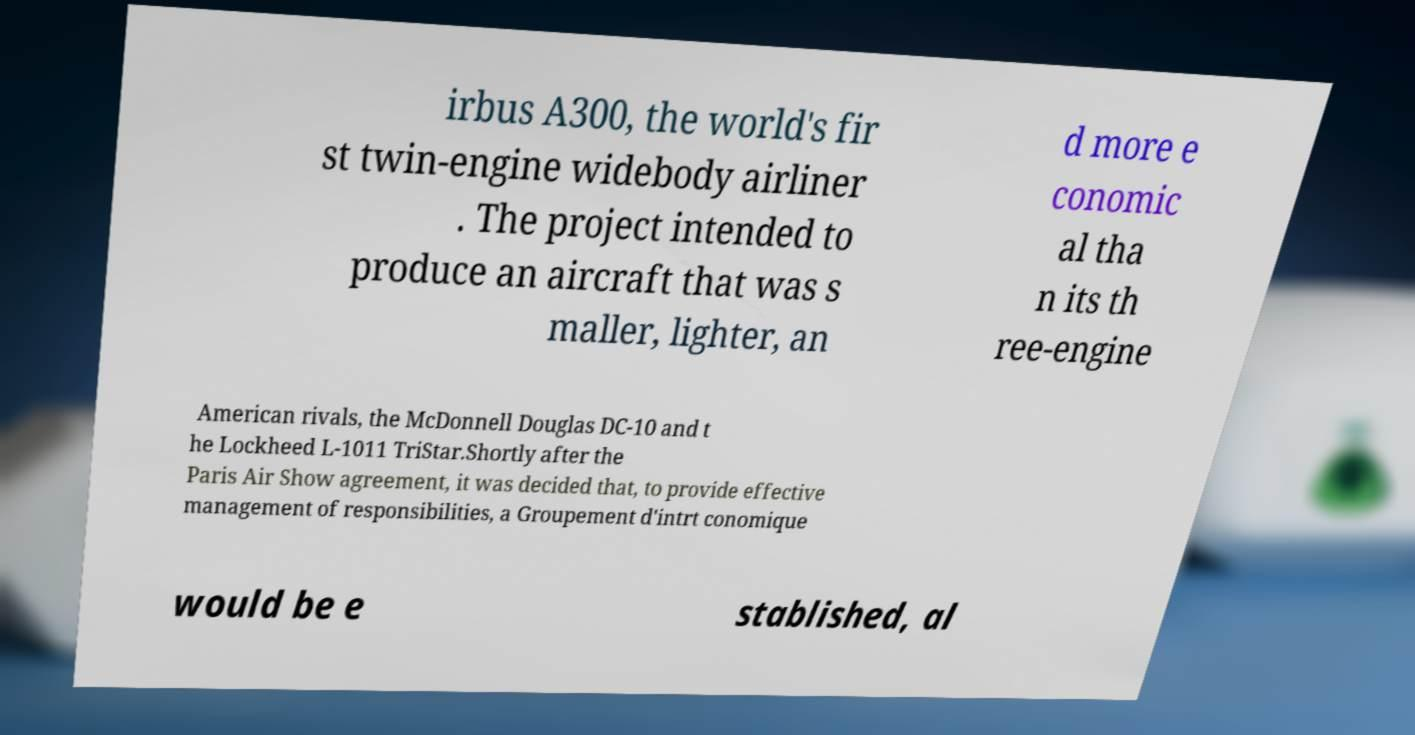Could you extract and type out the text from this image? irbus A300, the world's fir st twin-engine widebody airliner . The project intended to produce an aircraft that was s maller, lighter, an d more e conomic al tha n its th ree-engine American rivals, the McDonnell Douglas DC-10 and t he Lockheed L-1011 TriStar.Shortly after the Paris Air Show agreement, it was decided that, to provide effective management of responsibilities, a Groupement d'intrt conomique would be e stablished, al 